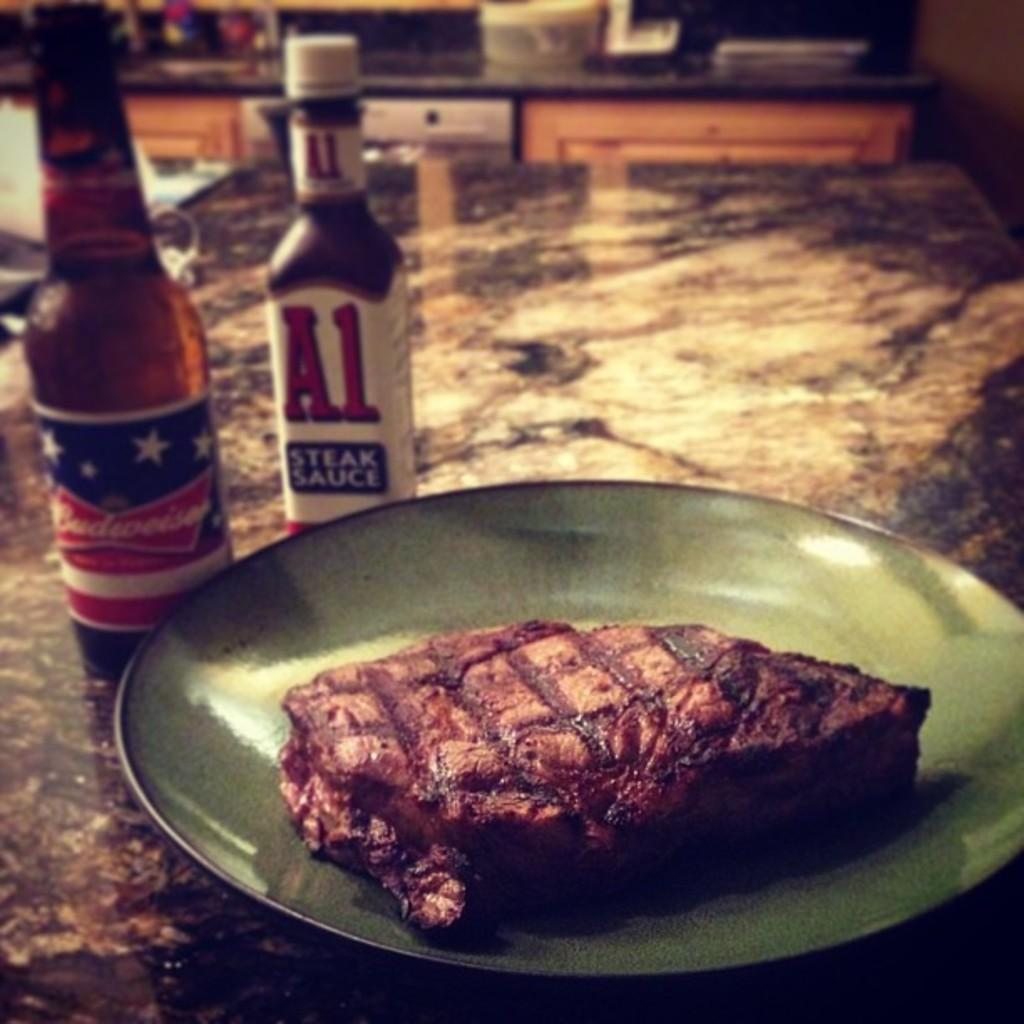<image>
Summarize the visual content of the image. Bottles of Budweiser and A1 sauce sit next to a plate of steak. 